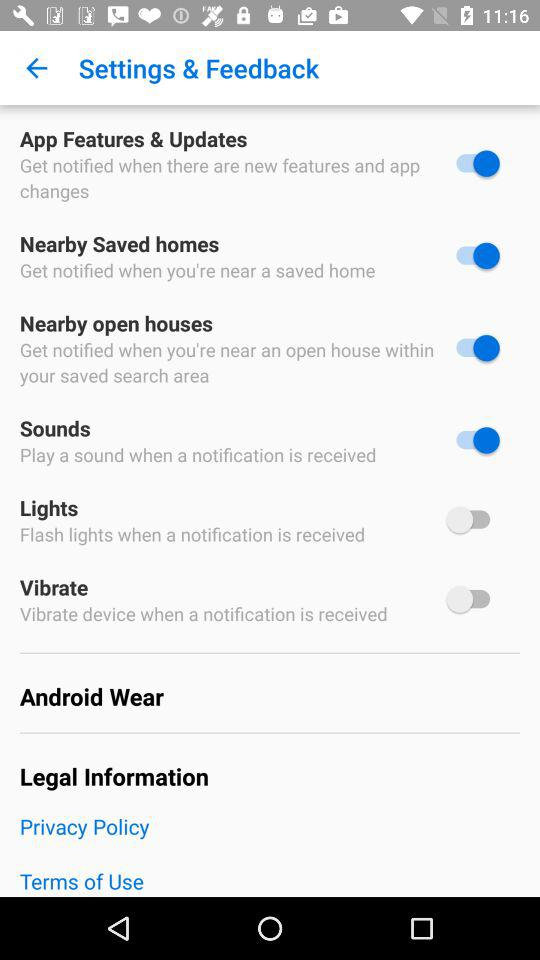What is the status of "Nearby Saved homes"? The status is "on". 